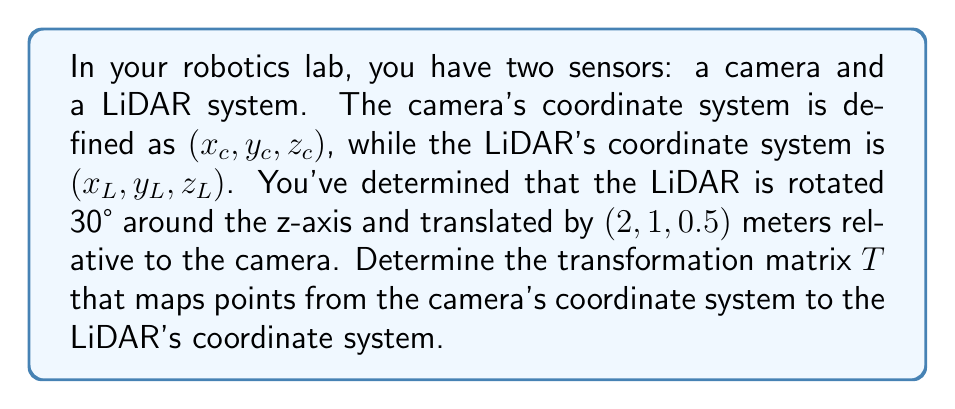Help me with this question. To solve this problem, we need to combine rotation and translation transformations:

1. Rotation matrix for 30° around the z-axis:
   $$R_z(30°) = \begin{bmatrix}
   \cos(30°) & -\sin(30°) & 0 & 0 \\
   \sin(30°) & \cos(30°) & 0 & 0 \\
   0 & 0 & 1 & 0 \\
   0 & 0 & 0 & 1
   \end{bmatrix}$$

2. Translation matrix for $(2, 1, 0.5)$:
   $$T_{trans} = \begin{bmatrix}
   1 & 0 & 0 & 2 \\
   0 & 1 & 0 & 1 \\
   0 & 0 & 1 & 0.5 \\
   0 & 0 & 0 & 1
   \end{bmatrix}$$

3. The final transformation matrix $T$ is the product of these matrices:
   $$T = T_{trans} \cdot R_z(30°)$$

4. Multiply the matrices:
   $$T = \begin{bmatrix}
   1 & 0 & 0 & 2 \\
   0 & 1 & 0 & 1 \\
   0 & 0 & 1 & 0.5 \\
   0 & 0 & 0 & 1
   \end{bmatrix} \cdot 
   \begin{bmatrix}
   \frac{\sqrt{3}}{2} & -\frac{1}{2} & 0 & 0 \\
   \frac{1}{2} & \frac{\sqrt{3}}{2} & 0 & 0 \\
   0 & 0 & 1 & 0 \\
   0 & 0 & 0 & 1
   \end{bmatrix}$$

5. Perform matrix multiplication:
   $$T = \begin{bmatrix}
   \frac{\sqrt{3}}{2} & -\frac{1}{2} & 0 & 2 \\
   \frac{1}{2} & \frac{\sqrt{3}}{2} & 0 & 1 \\
   0 & 0 & 1 & 0.5 \\
   0 & 0 & 0 & 1
   \end{bmatrix}$$

This transformation matrix $T$ maps points from the camera's coordinate system to the LiDAR's coordinate system.
Answer: $$T = \begin{bmatrix}
\frac{\sqrt{3}}{2} & -\frac{1}{2} & 0 & 2 \\
\frac{1}{2} & \frac{\sqrt{3}}{2} & 0 & 1 \\
0 & 0 & 1 & 0.5 \\
0 & 0 & 0 & 1
\end{bmatrix}$$ 